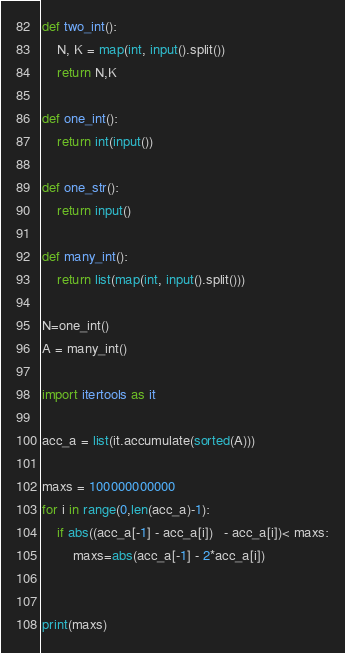Convert code to text. <code><loc_0><loc_0><loc_500><loc_500><_Python_>def two_int():
    N, K = map(int, input().split())
    return N,K

def one_int():
    return int(input())

def one_str():
    return input()

def many_int():
    return list(map(int, input().split()))

N=one_int()
A = many_int()

import itertools as it

acc_a = list(it.accumulate(sorted(A)))

maxs = 100000000000
for i in range(0,len(acc_a)-1):
    if abs((acc_a[-1] - acc_a[i])   - acc_a[i])< maxs:
        maxs=abs(acc_a[-1] - 2*acc_a[i])


print(maxs)

</code> 